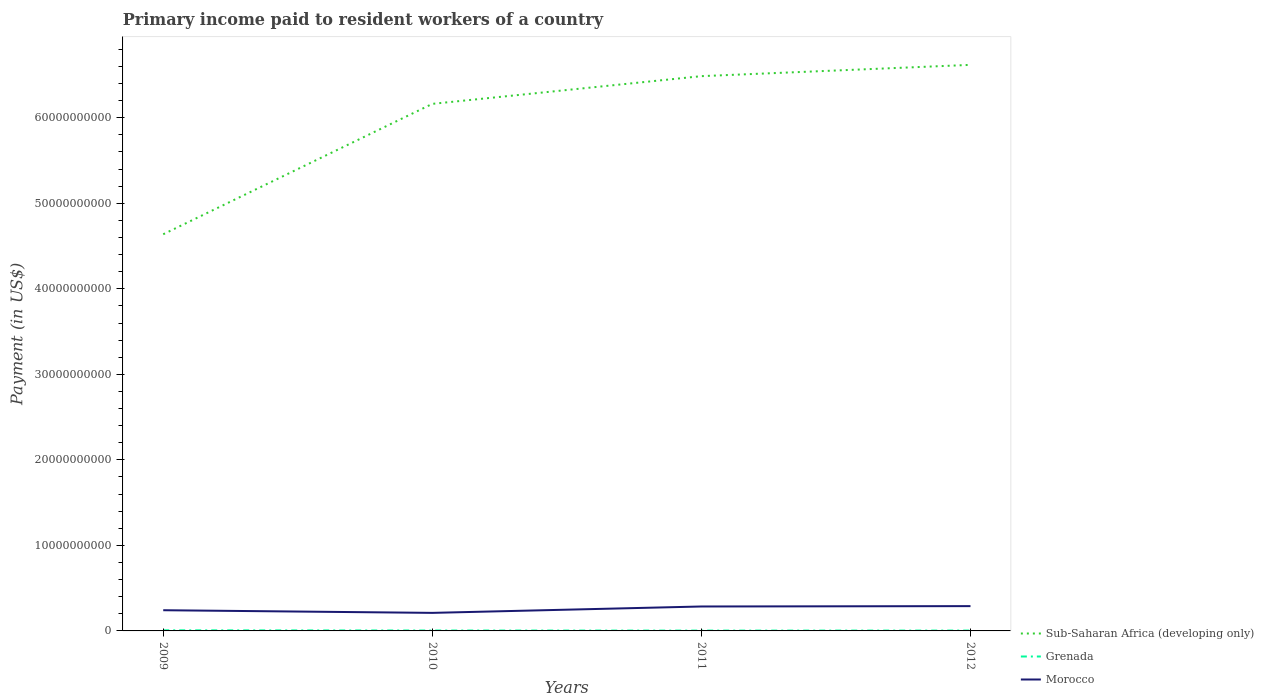Is the number of lines equal to the number of legend labels?
Give a very brief answer. Yes. Across all years, what is the maximum amount paid to workers in Morocco?
Offer a terse response. 2.11e+09. In which year was the amount paid to workers in Grenada maximum?
Your response must be concise. 2011. What is the total amount paid to workers in Morocco in the graph?
Your answer should be very brief. -4.79e+08. What is the difference between the highest and the second highest amount paid to workers in Grenada?
Offer a terse response. 3.36e+07. What is the difference between the highest and the lowest amount paid to workers in Sub-Saharan Africa (developing only)?
Your answer should be very brief. 3. Is the amount paid to workers in Sub-Saharan Africa (developing only) strictly greater than the amount paid to workers in Morocco over the years?
Your answer should be compact. No. How many lines are there?
Make the answer very short. 3. Are the values on the major ticks of Y-axis written in scientific E-notation?
Give a very brief answer. No. Does the graph contain any zero values?
Give a very brief answer. No. Does the graph contain grids?
Keep it short and to the point. No. Where does the legend appear in the graph?
Ensure brevity in your answer.  Bottom right. How many legend labels are there?
Keep it short and to the point. 3. What is the title of the graph?
Provide a short and direct response. Primary income paid to resident workers of a country. What is the label or title of the Y-axis?
Give a very brief answer. Payment (in US$). What is the Payment (in US$) in Sub-Saharan Africa (developing only) in 2009?
Give a very brief answer. 4.64e+1. What is the Payment (in US$) in Grenada in 2009?
Give a very brief answer. 7.12e+07. What is the Payment (in US$) of Morocco in 2009?
Offer a very short reply. 2.42e+09. What is the Payment (in US$) in Sub-Saharan Africa (developing only) in 2010?
Offer a terse response. 6.16e+1. What is the Payment (in US$) of Grenada in 2010?
Your answer should be compact. 4.70e+07. What is the Payment (in US$) in Morocco in 2010?
Give a very brief answer. 2.11e+09. What is the Payment (in US$) of Sub-Saharan Africa (developing only) in 2011?
Keep it short and to the point. 6.49e+1. What is the Payment (in US$) in Grenada in 2011?
Give a very brief answer. 3.75e+07. What is the Payment (in US$) in Morocco in 2011?
Offer a terse response. 2.86e+09. What is the Payment (in US$) in Sub-Saharan Africa (developing only) in 2012?
Give a very brief answer. 6.62e+1. What is the Payment (in US$) in Grenada in 2012?
Offer a terse response. 4.13e+07. What is the Payment (in US$) in Morocco in 2012?
Make the answer very short. 2.90e+09. Across all years, what is the maximum Payment (in US$) of Sub-Saharan Africa (developing only)?
Give a very brief answer. 6.62e+1. Across all years, what is the maximum Payment (in US$) of Grenada?
Give a very brief answer. 7.12e+07. Across all years, what is the maximum Payment (in US$) of Morocco?
Ensure brevity in your answer.  2.90e+09. Across all years, what is the minimum Payment (in US$) in Sub-Saharan Africa (developing only)?
Keep it short and to the point. 4.64e+1. Across all years, what is the minimum Payment (in US$) of Grenada?
Provide a succinct answer. 3.75e+07. Across all years, what is the minimum Payment (in US$) in Morocco?
Keep it short and to the point. 2.11e+09. What is the total Payment (in US$) in Sub-Saharan Africa (developing only) in the graph?
Your answer should be very brief. 2.39e+11. What is the total Payment (in US$) of Grenada in the graph?
Your response must be concise. 1.97e+08. What is the total Payment (in US$) of Morocco in the graph?
Offer a very short reply. 1.03e+1. What is the difference between the Payment (in US$) in Sub-Saharan Africa (developing only) in 2009 and that in 2010?
Offer a very short reply. -1.52e+1. What is the difference between the Payment (in US$) in Grenada in 2009 and that in 2010?
Offer a very short reply. 2.41e+07. What is the difference between the Payment (in US$) in Morocco in 2009 and that in 2010?
Give a very brief answer. 3.10e+08. What is the difference between the Payment (in US$) in Sub-Saharan Africa (developing only) in 2009 and that in 2011?
Keep it short and to the point. -1.85e+1. What is the difference between the Payment (in US$) of Grenada in 2009 and that in 2011?
Your response must be concise. 3.36e+07. What is the difference between the Payment (in US$) of Morocco in 2009 and that in 2011?
Offer a very short reply. -4.36e+08. What is the difference between the Payment (in US$) of Sub-Saharan Africa (developing only) in 2009 and that in 2012?
Offer a very short reply. -1.98e+1. What is the difference between the Payment (in US$) in Grenada in 2009 and that in 2012?
Keep it short and to the point. 2.99e+07. What is the difference between the Payment (in US$) in Morocco in 2009 and that in 2012?
Provide a succinct answer. -4.79e+08. What is the difference between the Payment (in US$) of Sub-Saharan Africa (developing only) in 2010 and that in 2011?
Make the answer very short. -3.24e+09. What is the difference between the Payment (in US$) of Grenada in 2010 and that in 2011?
Your response must be concise. 9.49e+06. What is the difference between the Payment (in US$) of Morocco in 2010 and that in 2011?
Give a very brief answer. -7.46e+08. What is the difference between the Payment (in US$) of Sub-Saharan Africa (developing only) in 2010 and that in 2012?
Your answer should be very brief. -4.56e+09. What is the difference between the Payment (in US$) of Grenada in 2010 and that in 2012?
Offer a very short reply. 5.75e+06. What is the difference between the Payment (in US$) of Morocco in 2010 and that in 2012?
Your answer should be compact. -7.89e+08. What is the difference between the Payment (in US$) in Sub-Saharan Africa (developing only) in 2011 and that in 2012?
Your response must be concise. -1.32e+09. What is the difference between the Payment (in US$) of Grenada in 2011 and that in 2012?
Your answer should be compact. -3.74e+06. What is the difference between the Payment (in US$) in Morocco in 2011 and that in 2012?
Provide a short and direct response. -4.30e+07. What is the difference between the Payment (in US$) of Sub-Saharan Africa (developing only) in 2009 and the Payment (in US$) of Grenada in 2010?
Give a very brief answer. 4.63e+1. What is the difference between the Payment (in US$) of Sub-Saharan Africa (developing only) in 2009 and the Payment (in US$) of Morocco in 2010?
Your response must be concise. 4.43e+1. What is the difference between the Payment (in US$) in Grenada in 2009 and the Payment (in US$) in Morocco in 2010?
Your answer should be compact. -2.04e+09. What is the difference between the Payment (in US$) of Sub-Saharan Africa (developing only) in 2009 and the Payment (in US$) of Grenada in 2011?
Provide a short and direct response. 4.63e+1. What is the difference between the Payment (in US$) of Sub-Saharan Africa (developing only) in 2009 and the Payment (in US$) of Morocco in 2011?
Offer a very short reply. 4.35e+1. What is the difference between the Payment (in US$) in Grenada in 2009 and the Payment (in US$) in Morocco in 2011?
Your answer should be compact. -2.79e+09. What is the difference between the Payment (in US$) of Sub-Saharan Africa (developing only) in 2009 and the Payment (in US$) of Grenada in 2012?
Offer a terse response. 4.63e+1. What is the difference between the Payment (in US$) of Sub-Saharan Africa (developing only) in 2009 and the Payment (in US$) of Morocco in 2012?
Your answer should be compact. 4.35e+1. What is the difference between the Payment (in US$) in Grenada in 2009 and the Payment (in US$) in Morocco in 2012?
Offer a very short reply. -2.83e+09. What is the difference between the Payment (in US$) of Sub-Saharan Africa (developing only) in 2010 and the Payment (in US$) of Grenada in 2011?
Provide a short and direct response. 6.16e+1. What is the difference between the Payment (in US$) in Sub-Saharan Africa (developing only) in 2010 and the Payment (in US$) in Morocco in 2011?
Your answer should be compact. 5.88e+1. What is the difference between the Payment (in US$) of Grenada in 2010 and the Payment (in US$) of Morocco in 2011?
Keep it short and to the point. -2.81e+09. What is the difference between the Payment (in US$) of Sub-Saharan Africa (developing only) in 2010 and the Payment (in US$) of Grenada in 2012?
Give a very brief answer. 6.16e+1. What is the difference between the Payment (in US$) in Sub-Saharan Africa (developing only) in 2010 and the Payment (in US$) in Morocco in 2012?
Your answer should be compact. 5.87e+1. What is the difference between the Payment (in US$) in Grenada in 2010 and the Payment (in US$) in Morocco in 2012?
Offer a very short reply. -2.85e+09. What is the difference between the Payment (in US$) of Sub-Saharan Africa (developing only) in 2011 and the Payment (in US$) of Grenada in 2012?
Your answer should be compact. 6.48e+1. What is the difference between the Payment (in US$) in Sub-Saharan Africa (developing only) in 2011 and the Payment (in US$) in Morocco in 2012?
Keep it short and to the point. 6.20e+1. What is the difference between the Payment (in US$) of Grenada in 2011 and the Payment (in US$) of Morocco in 2012?
Your answer should be compact. -2.86e+09. What is the average Payment (in US$) of Sub-Saharan Africa (developing only) per year?
Make the answer very short. 5.98e+1. What is the average Payment (in US$) of Grenada per year?
Your answer should be very brief. 4.93e+07. What is the average Payment (in US$) in Morocco per year?
Provide a succinct answer. 2.57e+09. In the year 2009, what is the difference between the Payment (in US$) of Sub-Saharan Africa (developing only) and Payment (in US$) of Grenada?
Offer a very short reply. 4.63e+1. In the year 2009, what is the difference between the Payment (in US$) of Sub-Saharan Africa (developing only) and Payment (in US$) of Morocco?
Keep it short and to the point. 4.40e+1. In the year 2009, what is the difference between the Payment (in US$) of Grenada and Payment (in US$) of Morocco?
Keep it short and to the point. -2.35e+09. In the year 2010, what is the difference between the Payment (in US$) of Sub-Saharan Africa (developing only) and Payment (in US$) of Grenada?
Provide a succinct answer. 6.16e+1. In the year 2010, what is the difference between the Payment (in US$) of Sub-Saharan Africa (developing only) and Payment (in US$) of Morocco?
Keep it short and to the point. 5.95e+1. In the year 2010, what is the difference between the Payment (in US$) in Grenada and Payment (in US$) in Morocco?
Offer a terse response. -2.06e+09. In the year 2011, what is the difference between the Payment (in US$) in Sub-Saharan Africa (developing only) and Payment (in US$) in Grenada?
Your answer should be compact. 6.48e+1. In the year 2011, what is the difference between the Payment (in US$) in Sub-Saharan Africa (developing only) and Payment (in US$) in Morocco?
Provide a short and direct response. 6.20e+1. In the year 2011, what is the difference between the Payment (in US$) in Grenada and Payment (in US$) in Morocco?
Keep it short and to the point. -2.82e+09. In the year 2012, what is the difference between the Payment (in US$) of Sub-Saharan Africa (developing only) and Payment (in US$) of Grenada?
Provide a short and direct response. 6.61e+1. In the year 2012, what is the difference between the Payment (in US$) of Sub-Saharan Africa (developing only) and Payment (in US$) of Morocco?
Provide a succinct answer. 6.33e+1. In the year 2012, what is the difference between the Payment (in US$) in Grenada and Payment (in US$) in Morocco?
Provide a succinct answer. -2.86e+09. What is the ratio of the Payment (in US$) in Sub-Saharan Africa (developing only) in 2009 to that in 2010?
Keep it short and to the point. 0.75. What is the ratio of the Payment (in US$) of Grenada in 2009 to that in 2010?
Your answer should be compact. 1.51. What is the ratio of the Payment (in US$) of Morocco in 2009 to that in 2010?
Make the answer very short. 1.15. What is the ratio of the Payment (in US$) of Sub-Saharan Africa (developing only) in 2009 to that in 2011?
Ensure brevity in your answer.  0.71. What is the ratio of the Payment (in US$) of Grenada in 2009 to that in 2011?
Provide a succinct answer. 1.9. What is the ratio of the Payment (in US$) in Morocco in 2009 to that in 2011?
Your answer should be very brief. 0.85. What is the ratio of the Payment (in US$) of Sub-Saharan Africa (developing only) in 2009 to that in 2012?
Offer a terse response. 0.7. What is the ratio of the Payment (in US$) of Grenada in 2009 to that in 2012?
Offer a very short reply. 1.72. What is the ratio of the Payment (in US$) in Morocco in 2009 to that in 2012?
Offer a terse response. 0.83. What is the ratio of the Payment (in US$) of Sub-Saharan Africa (developing only) in 2010 to that in 2011?
Offer a terse response. 0.95. What is the ratio of the Payment (in US$) of Grenada in 2010 to that in 2011?
Your answer should be compact. 1.25. What is the ratio of the Payment (in US$) of Morocco in 2010 to that in 2011?
Give a very brief answer. 0.74. What is the ratio of the Payment (in US$) of Sub-Saharan Africa (developing only) in 2010 to that in 2012?
Your response must be concise. 0.93. What is the ratio of the Payment (in US$) in Grenada in 2010 to that in 2012?
Provide a succinct answer. 1.14. What is the ratio of the Payment (in US$) in Morocco in 2010 to that in 2012?
Offer a very short reply. 0.73. What is the ratio of the Payment (in US$) in Sub-Saharan Africa (developing only) in 2011 to that in 2012?
Your response must be concise. 0.98. What is the ratio of the Payment (in US$) of Grenada in 2011 to that in 2012?
Your response must be concise. 0.91. What is the ratio of the Payment (in US$) in Morocco in 2011 to that in 2012?
Your response must be concise. 0.99. What is the difference between the highest and the second highest Payment (in US$) in Sub-Saharan Africa (developing only)?
Give a very brief answer. 1.32e+09. What is the difference between the highest and the second highest Payment (in US$) in Grenada?
Offer a terse response. 2.41e+07. What is the difference between the highest and the second highest Payment (in US$) in Morocco?
Provide a succinct answer. 4.30e+07. What is the difference between the highest and the lowest Payment (in US$) of Sub-Saharan Africa (developing only)?
Provide a short and direct response. 1.98e+1. What is the difference between the highest and the lowest Payment (in US$) of Grenada?
Give a very brief answer. 3.36e+07. What is the difference between the highest and the lowest Payment (in US$) of Morocco?
Provide a succinct answer. 7.89e+08. 